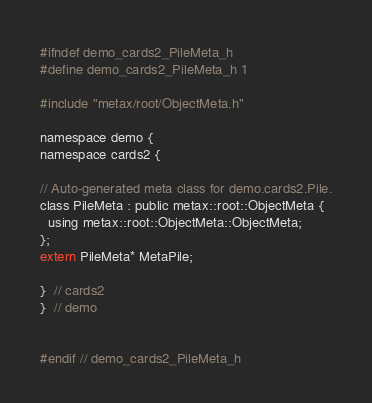Convert code to text. <code><loc_0><loc_0><loc_500><loc_500><_C_>#ifndef demo_cards2_PileMeta_h
#define demo_cards2_PileMeta_h 1

#include "metax/root/ObjectMeta.h"

namespace demo {
namespace cards2 {

// Auto-generated meta class for demo.cards2.Pile.
class PileMeta : public metax::root::ObjectMeta {
  using metax::root::ObjectMeta::ObjectMeta;
};
extern PileMeta* MetaPile;

}  // cards2
}  // demo


#endif // demo_cards2_PileMeta_h
</code> 